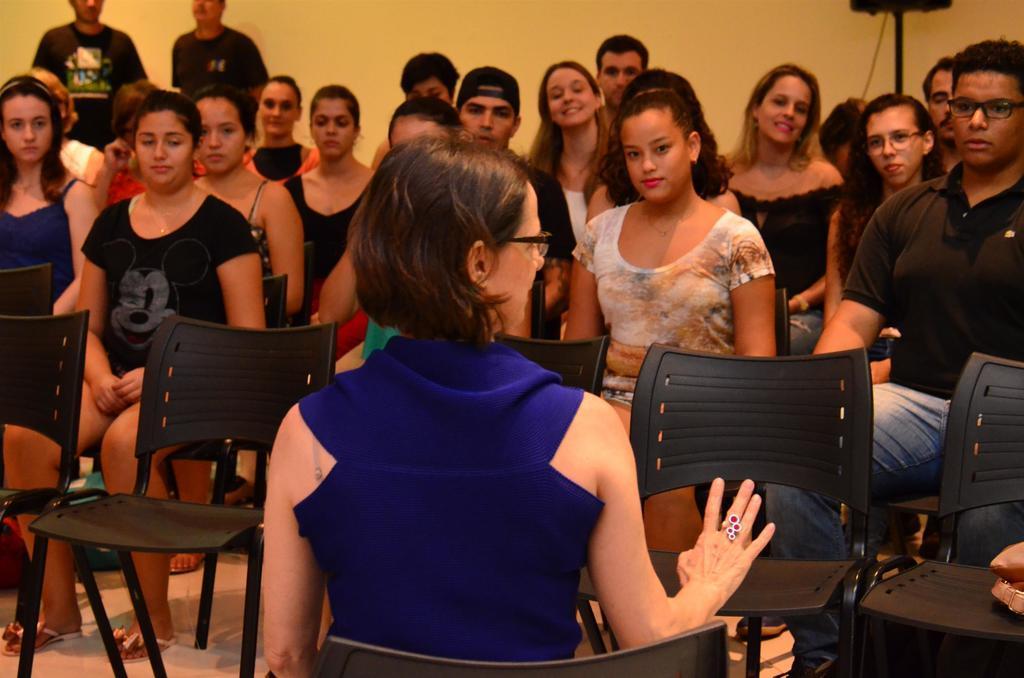Can you describe this image briefly? In this image i can see a group of people sitting on chairs. I can see some empty chairs in front, and in the background i can see a wall and some persons standing. 